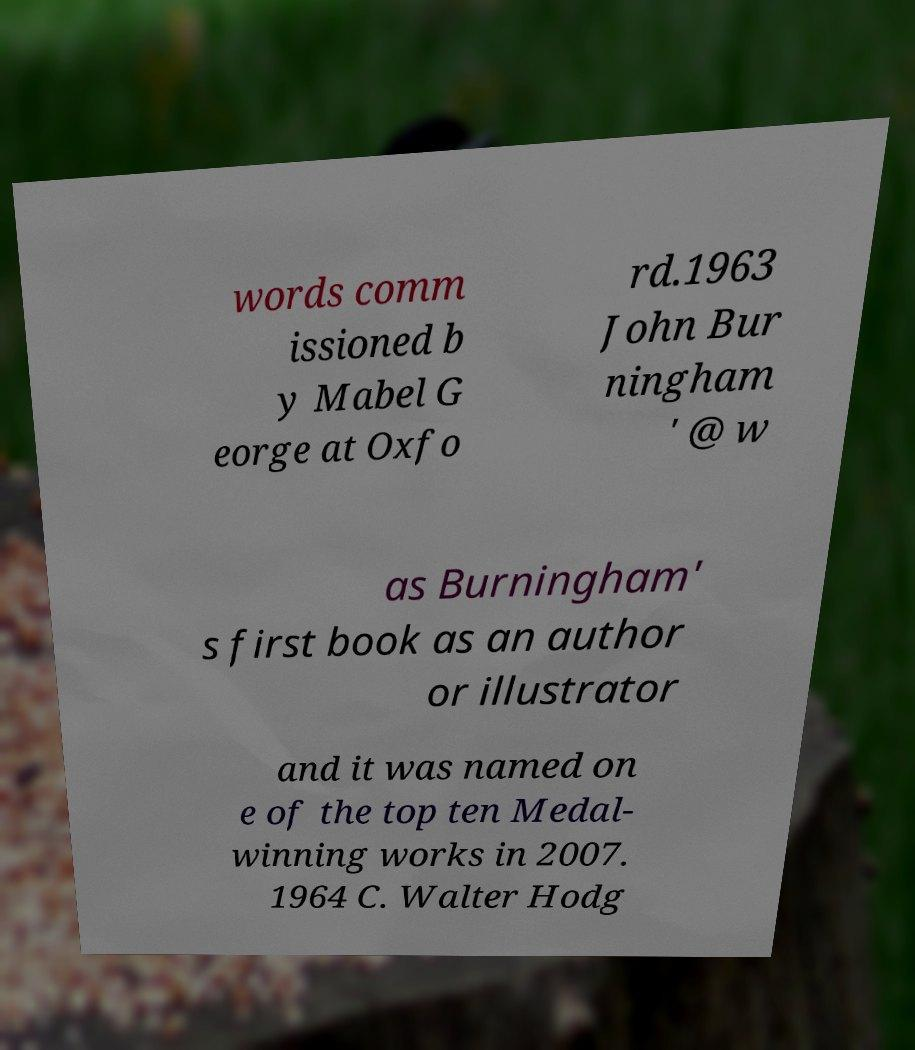Please identify and transcribe the text found in this image. words comm issioned b y Mabel G eorge at Oxfo rd.1963 John Bur ningham ' @ w as Burningham' s first book as an author or illustrator and it was named on e of the top ten Medal- winning works in 2007. 1964 C. Walter Hodg 